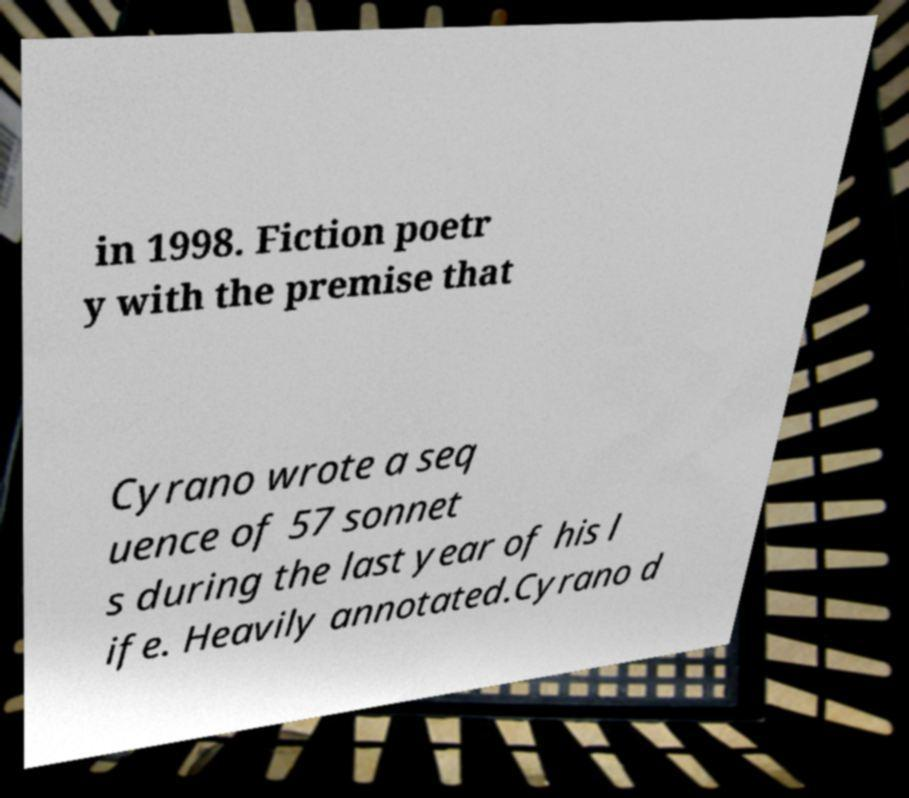Could you extract and type out the text from this image? in 1998. Fiction poetr y with the premise that Cyrano wrote a seq uence of 57 sonnet s during the last year of his l ife. Heavily annotated.Cyrano d 